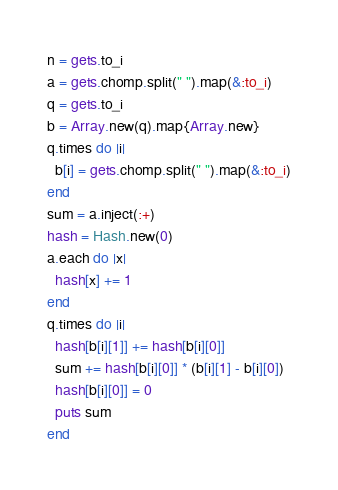<code> <loc_0><loc_0><loc_500><loc_500><_Ruby_>n = gets.to_i
a = gets.chomp.split(" ").map(&:to_i)
q = gets.to_i
b = Array.new(q).map{Array.new}
q.times do |i|
  b[i] = gets.chomp.split(" ").map(&:to_i)
end
sum = a.inject(:+)
hash = Hash.new(0)
a.each do |x|
  hash[x] += 1
end
q.times do |i|
  hash[b[i][1]] += hash[b[i][0]]
  sum += hash[b[i][0]] * (b[i][1] - b[i][0])
  hash[b[i][0]] = 0
  puts sum
end</code> 